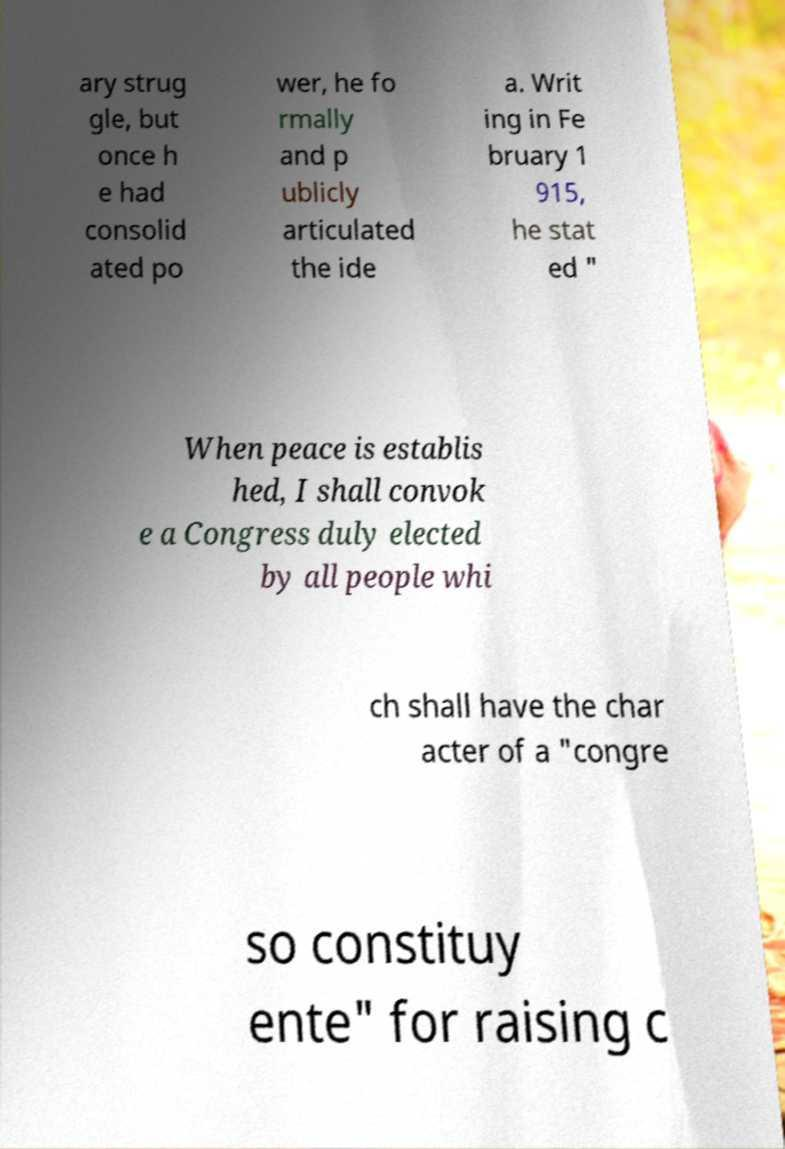Can you accurately transcribe the text from the provided image for me? ary strug gle, but once h e had consolid ated po wer, he fo rmally and p ublicly articulated the ide a. Writ ing in Fe bruary 1 915, he stat ed " When peace is establis hed, I shall convok e a Congress duly elected by all people whi ch shall have the char acter of a "congre so constituy ente" for raising c 